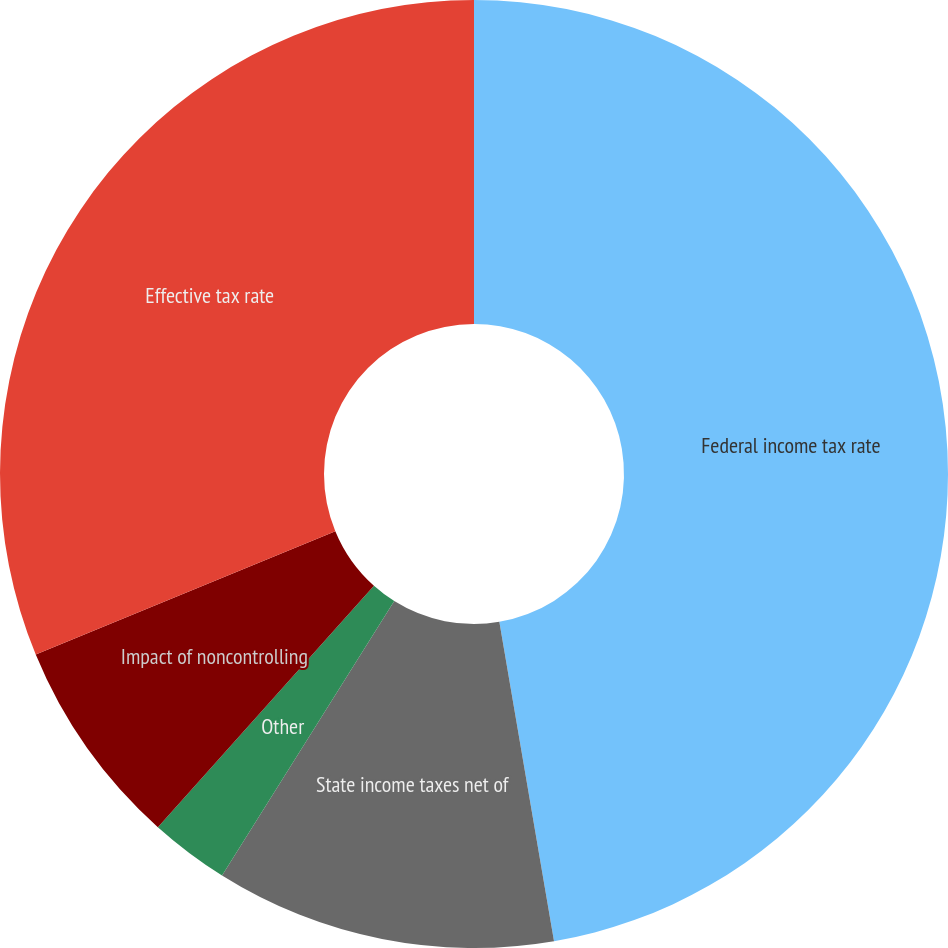Convert chart to OTSL. <chart><loc_0><loc_0><loc_500><loc_500><pie_chart><fcel>Federal income tax rate<fcel>State income taxes net of<fcel>Other<fcel>Impact of noncontrolling<fcel>Effective tax rate<nl><fcel>47.3%<fcel>11.62%<fcel>2.7%<fcel>7.16%<fcel>31.22%<nl></chart> 